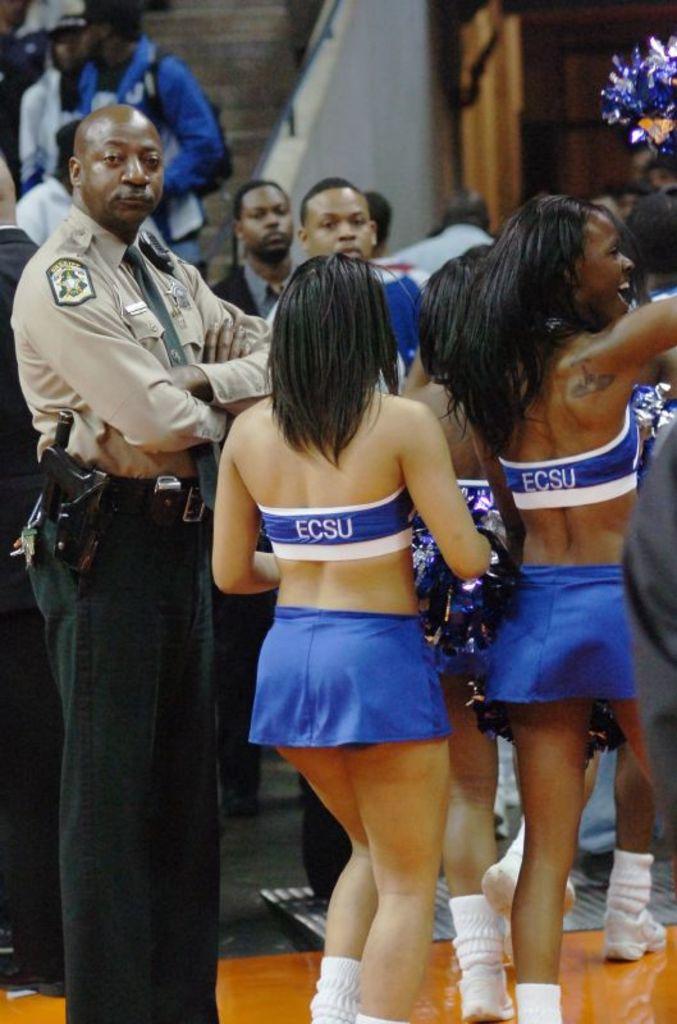What school are the cheerleaders from?
Give a very brief answer. Ecsu. 